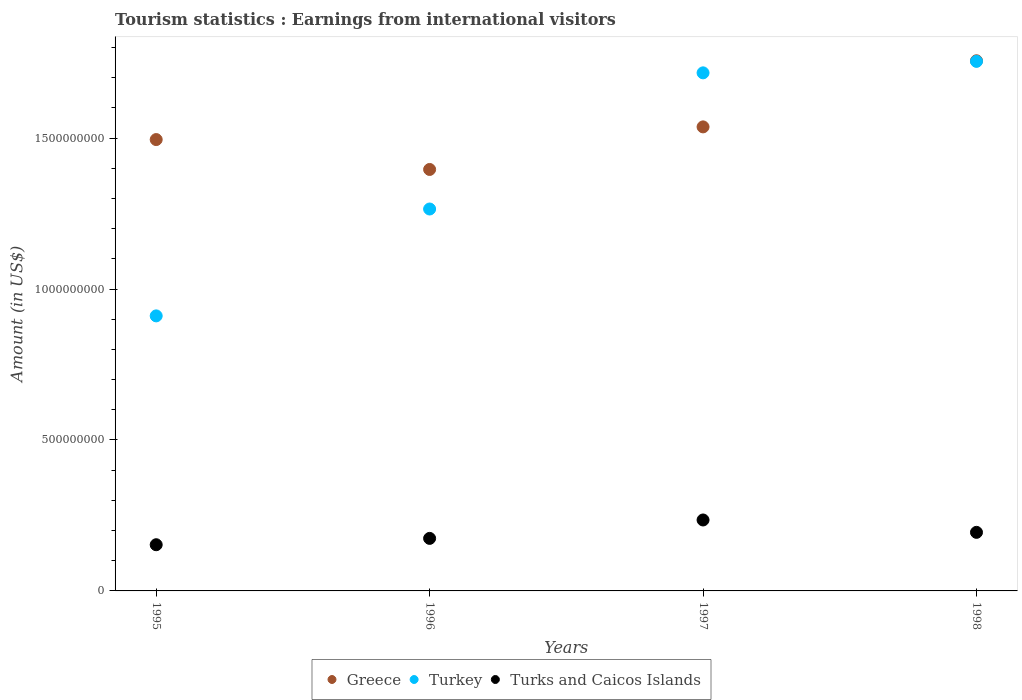How many different coloured dotlines are there?
Your answer should be compact. 3. Is the number of dotlines equal to the number of legend labels?
Give a very brief answer. Yes. What is the earnings from international visitors in Turks and Caicos Islands in 1997?
Ensure brevity in your answer.  2.35e+08. Across all years, what is the maximum earnings from international visitors in Turkey?
Provide a succinct answer. 1.75e+09. Across all years, what is the minimum earnings from international visitors in Turks and Caicos Islands?
Your answer should be compact. 1.53e+08. What is the total earnings from international visitors in Turks and Caicos Islands in the graph?
Keep it short and to the point. 7.56e+08. What is the difference between the earnings from international visitors in Turkey in 1997 and that in 1998?
Ensure brevity in your answer.  -3.80e+07. What is the difference between the earnings from international visitors in Turks and Caicos Islands in 1997 and the earnings from international visitors in Greece in 1996?
Keep it short and to the point. -1.16e+09. What is the average earnings from international visitors in Turks and Caicos Islands per year?
Your answer should be compact. 1.89e+08. In the year 1995, what is the difference between the earnings from international visitors in Turks and Caicos Islands and earnings from international visitors in Turkey?
Your answer should be compact. -7.58e+08. What is the ratio of the earnings from international visitors in Greece in 1995 to that in 1997?
Keep it short and to the point. 0.97. Is the earnings from international visitors in Greece in 1995 less than that in 1998?
Make the answer very short. Yes. Is the difference between the earnings from international visitors in Turks and Caicos Islands in 1995 and 1996 greater than the difference between the earnings from international visitors in Turkey in 1995 and 1996?
Make the answer very short. Yes. What is the difference between the highest and the second highest earnings from international visitors in Turks and Caicos Islands?
Provide a short and direct response. 4.10e+07. What is the difference between the highest and the lowest earnings from international visitors in Turkey?
Your answer should be very brief. 8.43e+08. Is the sum of the earnings from international visitors in Turkey in 1995 and 1997 greater than the maximum earnings from international visitors in Turks and Caicos Islands across all years?
Make the answer very short. Yes. Is the earnings from international visitors in Greece strictly less than the earnings from international visitors in Turkey over the years?
Offer a terse response. No. Does the graph contain grids?
Give a very brief answer. No. Where does the legend appear in the graph?
Your response must be concise. Bottom center. How are the legend labels stacked?
Your answer should be compact. Horizontal. What is the title of the graph?
Provide a short and direct response. Tourism statistics : Earnings from international visitors. What is the label or title of the X-axis?
Your answer should be compact. Years. What is the label or title of the Y-axis?
Ensure brevity in your answer.  Amount (in US$). What is the Amount (in US$) of Greece in 1995?
Ensure brevity in your answer.  1.50e+09. What is the Amount (in US$) of Turkey in 1995?
Offer a terse response. 9.11e+08. What is the Amount (in US$) of Turks and Caicos Islands in 1995?
Give a very brief answer. 1.53e+08. What is the Amount (in US$) of Greece in 1996?
Provide a short and direct response. 1.40e+09. What is the Amount (in US$) of Turkey in 1996?
Ensure brevity in your answer.  1.26e+09. What is the Amount (in US$) in Turks and Caicos Islands in 1996?
Provide a short and direct response. 1.74e+08. What is the Amount (in US$) of Greece in 1997?
Provide a succinct answer. 1.54e+09. What is the Amount (in US$) in Turkey in 1997?
Give a very brief answer. 1.72e+09. What is the Amount (in US$) in Turks and Caicos Islands in 1997?
Ensure brevity in your answer.  2.35e+08. What is the Amount (in US$) in Greece in 1998?
Your response must be concise. 1.76e+09. What is the Amount (in US$) of Turkey in 1998?
Keep it short and to the point. 1.75e+09. What is the Amount (in US$) of Turks and Caicos Islands in 1998?
Give a very brief answer. 1.94e+08. Across all years, what is the maximum Amount (in US$) of Greece?
Make the answer very short. 1.76e+09. Across all years, what is the maximum Amount (in US$) in Turkey?
Provide a short and direct response. 1.75e+09. Across all years, what is the maximum Amount (in US$) of Turks and Caicos Islands?
Your answer should be very brief. 2.35e+08. Across all years, what is the minimum Amount (in US$) of Greece?
Keep it short and to the point. 1.40e+09. Across all years, what is the minimum Amount (in US$) in Turkey?
Your response must be concise. 9.11e+08. Across all years, what is the minimum Amount (in US$) of Turks and Caicos Islands?
Provide a short and direct response. 1.53e+08. What is the total Amount (in US$) of Greece in the graph?
Give a very brief answer. 6.18e+09. What is the total Amount (in US$) of Turkey in the graph?
Offer a terse response. 5.65e+09. What is the total Amount (in US$) of Turks and Caicos Islands in the graph?
Offer a very short reply. 7.56e+08. What is the difference between the Amount (in US$) of Greece in 1995 and that in 1996?
Provide a succinct answer. 9.90e+07. What is the difference between the Amount (in US$) in Turkey in 1995 and that in 1996?
Offer a terse response. -3.54e+08. What is the difference between the Amount (in US$) in Turks and Caicos Islands in 1995 and that in 1996?
Keep it short and to the point. -2.10e+07. What is the difference between the Amount (in US$) of Greece in 1995 and that in 1997?
Give a very brief answer. -4.20e+07. What is the difference between the Amount (in US$) of Turkey in 1995 and that in 1997?
Offer a very short reply. -8.05e+08. What is the difference between the Amount (in US$) of Turks and Caicos Islands in 1995 and that in 1997?
Keep it short and to the point. -8.20e+07. What is the difference between the Amount (in US$) of Greece in 1995 and that in 1998?
Keep it short and to the point. -2.61e+08. What is the difference between the Amount (in US$) of Turkey in 1995 and that in 1998?
Offer a terse response. -8.43e+08. What is the difference between the Amount (in US$) of Turks and Caicos Islands in 1995 and that in 1998?
Offer a very short reply. -4.10e+07. What is the difference between the Amount (in US$) in Greece in 1996 and that in 1997?
Give a very brief answer. -1.41e+08. What is the difference between the Amount (in US$) of Turkey in 1996 and that in 1997?
Make the answer very short. -4.51e+08. What is the difference between the Amount (in US$) in Turks and Caicos Islands in 1996 and that in 1997?
Keep it short and to the point. -6.10e+07. What is the difference between the Amount (in US$) of Greece in 1996 and that in 1998?
Your answer should be very brief. -3.60e+08. What is the difference between the Amount (in US$) of Turkey in 1996 and that in 1998?
Make the answer very short. -4.89e+08. What is the difference between the Amount (in US$) of Turks and Caicos Islands in 1996 and that in 1998?
Provide a succinct answer. -2.00e+07. What is the difference between the Amount (in US$) of Greece in 1997 and that in 1998?
Your answer should be compact. -2.19e+08. What is the difference between the Amount (in US$) of Turkey in 1997 and that in 1998?
Your answer should be very brief. -3.80e+07. What is the difference between the Amount (in US$) in Turks and Caicos Islands in 1997 and that in 1998?
Offer a very short reply. 4.10e+07. What is the difference between the Amount (in US$) of Greece in 1995 and the Amount (in US$) of Turkey in 1996?
Your answer should be compact. 2.30e+08. What is the difference between the Amount (in US$) in Greece in 1995 and the Amount (in US$) in Turks and Caicos Islands in 1996?
Provide a short and direct response. 1.32e+09. What is the difference between the Amount (in US$) of Turkey in 1995 and the Amount (in US$) of Turks and Caicos Islands in 1996?
Ensure brevity in your answer.  7.37e+08. What is the difference between the Amount (in US$) of Greece in 1995 and the Amount (in US$) of Turkey in 1997?
Your answer should be compact. -2.21e+08. What is the difference between the Amount (in US$) in Greece in 1995 and the Amount (in US$) in Turks and Caicos Islands in 1997?
Offer a terse response. 1.26e+09. What is the difference between the Amount (in US$) in Turkey in 1995 and the Amount (in US$) in Turks and Caicos Islands in 1997?
Offer a terse response. 6.76e+08. What is the difference between the Amount (in US$) of Greece in 1995 and the Amount (in US$) of Turkey in 1998?
Provide a succinct answer. -2.59e+08. What is the difference between the Amount (in US$) of Greece in 1995 and the Amount (in US$) of Turks and Caicos Islands in 1998?
Keep it short and to the point. 1.30e+09. What is the difference between the Amount (in US$) in Turkey in 1995 and the Amount (in US$) in Turks and Caicos Islands in 1998?
Your answer should be very brief. 7.17e+08. What is the difference between the Amount (in US$) of Greece in 1996 and the Amount (in US$) of Turkey in 1997?
Make the answer very short. -3.20e+08. What is the difference between the Amount (in US$) in Greece in 1996 and the Amount (in US$) in Turks and Caicos Islands in 1997?
Keep it short and to the point. 1.16e+09. What is the difference between the Amount (in US$) of Turkey in 1996 and the Amount (in US$) of Turks and Caicos Islands in 1997?
Keep it short and to the point. 1.03e+09. What is the difference between the Amount (in US$) of Greece in 1996 and the Amount (in US$) of Turkey in 1998?
Make the answer very short. -3.58e+08. What is the difference between the Amount (in US$) of Greece in 1996 and the Amount (in US$) of Turks and Caicos Islands in 1998?
Give a very brief answer. 1.20e+09. What is the difference between the Amount (in US$) of Turkey in 1996 and the Amount (in US$) of Turks and Caicos Islands in 1998?
Provide a succinct answer. 1.07e+09. What is the difference between the Amount (in US$) of Greece in 1997 and the Amount (in US$) of Turkey in 1998?
Provide a short and direct response. -2.17e+08. What is the difference between the Amount (in US$) in Greece in 1997 and the Amount (in US$) in Turks and Caicos Islands in 1998?
Provide a short and direct response. 1.34e+09. What is the difference between the Amount (in US$) of Turkey in 1997 and the Amount (in US$) of Turks and Caicos Islands in 1998?
Provide a succinct answer. 1.52e+09. What is the average Amount (in US$) of Greece per year?
Your answer should be compact. 1.55e+09. What is the average Amount (in US$) in Turkey per year?
Ensure brevity in your answer.  1.41e+09. What is the average Amount (in US$) in Turks and Caicos Islands per year?
Your answer should be very brief. 1.89e+08. In the year 1995, what is the difference between the Amount (in US$) of Greece and Amount (in US$) of Turkey?
Provide a short and direct response. 5.84e+08. In the year 1995, what is the difference between the Amount (in US$) of Greece and Amount (in US$) of Turks and Caicos Islands?
Keep it short and to the point. 1.34e+09. In the year 1995, what is the difference between the Amount (in US$) in Turkey and Amount (in US$) in Turks and Caicos Islands?
Make the answer very short. 7.58e+08. In the year 1996, what is the difference between the Amount (in US$) of Greece and Amount (in US$) of Turkey?
Ensure brevity in your answer.  1.31e+08. In the year 1996, what is the difference between the Amount (in US$) in Greece and Amount (in US$) in Turks and Caicos Islands?
Provide a succinct answer. 1.22e+09. In the year 1996, what is the difference between the Amount (in US$) in Turkey and Amount (in US$) in Turks and Caicos Islands?
Your response must be concise. 1.09e+09. In the year 1997, what is the difference between the Amount (in US$) of Greece and Amount (in US$) of Turkey?
Your answer should be compact. -1.79e+08. In the year 1997, what is the difference between the Amount (in US$) of Greece and Amount (in US$) of Turks and Caicos Islands?
Provide a succinct answer. 1.30e+09. In the year 1997, what is the difference between the Amount (in US$) in Turkey and Amount (in US$) in Turks and Caicos Islands?
Make the answer very short. 1.48e+09. In the year 1998, what is the difference between the Amount (in US$) in Greece and Amount (in US$) in Turkey?
Keep it short and to the point. 2.00e+06. In the year 1998, what is the difference between the Amount (in US$) in Greece and Amount (in US$) in Turks and Caicos Islands?
Offer a terse response. 1.56e+09. In the year 1998, what is the difference between the Amount (in US$) of Turkey and Amount (in US$) of Turks and Caicos Islands?
Keep it short and to the point. 1.56e+09. What is the ratio of the Amount (in US$) of Greece in 1995 to that in 1996?
Offer a terse response. 1.07. What is the ratio of the Amount (in US$) of Turkey in 1995 to that in 1996?
Offer a terse response. 0.72. What is the ratio of the Amount (in US$) of Turks and Caicos Islands in 1995 to that in 1996?
Make the answer very short. 0.88. What is the ratio of the Amount (in US$) in Greece in 1995 to that in 1997?
Make the answer very short. 0.97. What is the ratio of the Amount (in US$) in Turkey in 1995 to that in 1997?
Provide a succinct answer. 0.53. What is the ratio of the Amount (in US$) of Turks and Caicos Islands in 1995 to that in 1997?
Offer a terse response. 0.65. What is the ratio of the Amount (in US$) in Greece in 1995 to that in 1998?
Your response must be concise. 0.85. What is the ratio of the Amount (in US$) in Turkey in 1995 to that in 1998?
Your answer should be very brief. 0.52. What is the ratio of the Amount (in US$) of Turks and Caicos Islands in 1995 to that in 1998?
Offer a terse response. 0.79. What is the ratio of the Amount (in US$) in Greece in 1996 to that in 1997?
Offer a terse response. 0.91. What is the ratio of the Amount (in US$) in Turkey in 1996 to that in 1997?
Offer a very short reply. 0.74. What is the ratio of the Amount (in US$) of Turks and Caicos Islands in 1996 to that in 1997?
Keep it short and to the point. 0.74. What is the ratio of the Amount (in US$) of Greece in 1996 to that in 1998?
Offer a terse response. 0.8. What is the ratio of the Amount (in US$) of Turkey in 1996 to that in 1998?
Give a very brief answer. 0.72. What is the ratio of the Amount (in US$) in Turks and Caicos Islands in 1996 to that in 1998?
Your answer should be very brief. 0.9. What is the ratio of the Amount (in US$) in Greece in 1997 to that in 1998?
Your answer should be compact. 0.88. What is the ratio of the Amount (in US$) of Turkey in 1997 to that in 1998?
Ensure brevity in your answer.  0.98. What is the ratio of the Amount (in US$) of Turks and Caicos Islands in 1997 to that in 1998?
Provide a short and direct response. 1.21. What is the difference between the highest and the second highest Amount (in US$) of Greece?
Make the answer very short. 2.19e+08. What is the difference between the highest and the second highest Amount (in US$) of Turkey?
Make the answer very short. 3.80e+07. What is the difference between the highest and the second highest Amount (in US$) of Turks and Caicos Islands?
Give a very brief answer. 4.10e+07. What is the difference between the highest and the lowest Amount (in US$) of Greece?
Offer a terse response. 3.60e+08. What is the difference between the highest and the lowest Amount (in US$) in Turkey?
Offer a very short reply. 8.43e+08. What is the difference between the highest and the lowest Amount (in US$) of Turks and Caicos Islands?
Keep it short and to the point. 8.20e+07. 